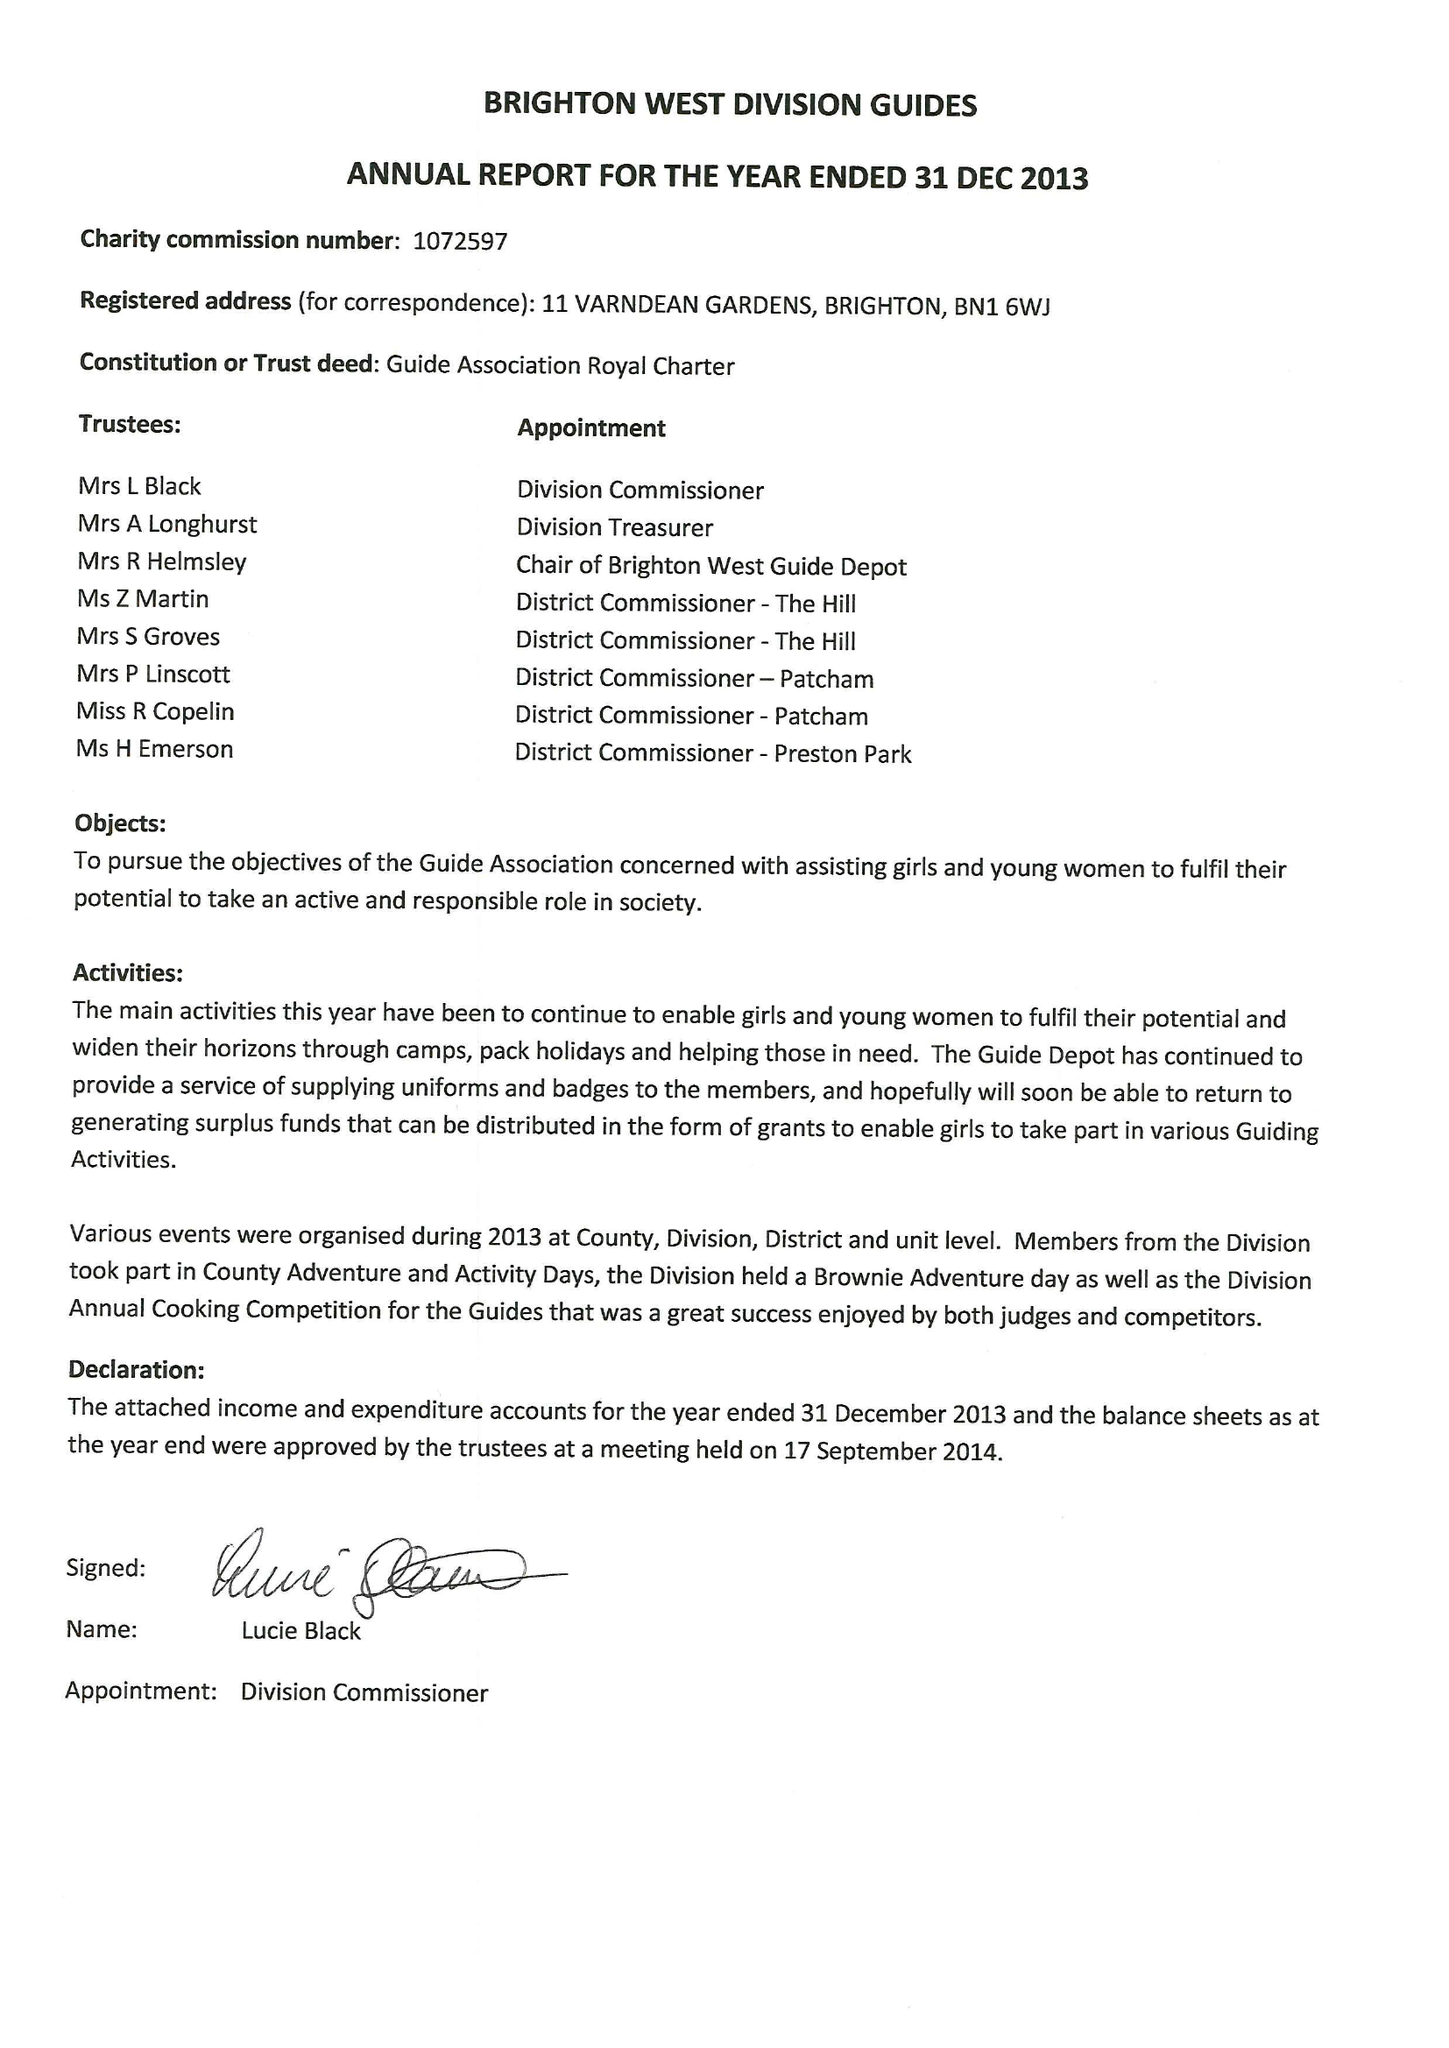What is the value for the income_annually_in_british_pounds?
Answer the question using a single word or phrase. 31935.00 